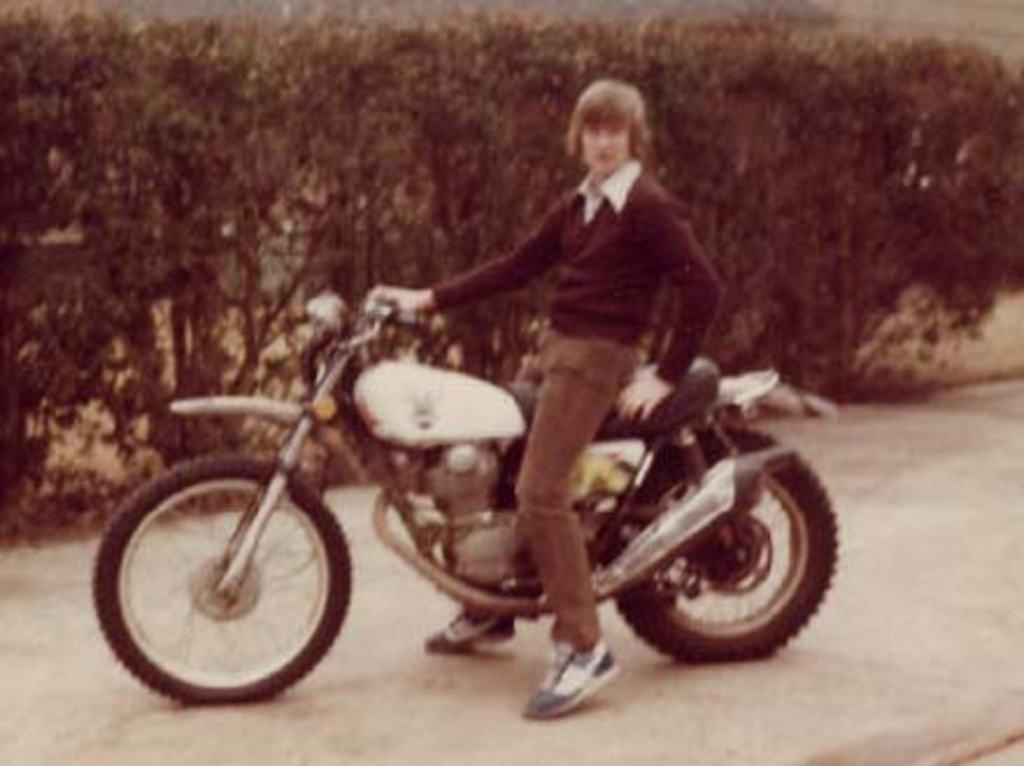Who is in the image? There is a man in the image. What is the man doing in the image? The man is sitting on a motorbike. Where is the motorbike located? The motorbike is on the road. What can be seen in the background of the image? There are trees in the background of the image. What type of hook can be seen on the man's motorbike in the image? There is no hook visible on the man's motorbike in the image. How many rings is the man wearing on his fingers in the image? There is no information about rings or the man's fingers in the image. 